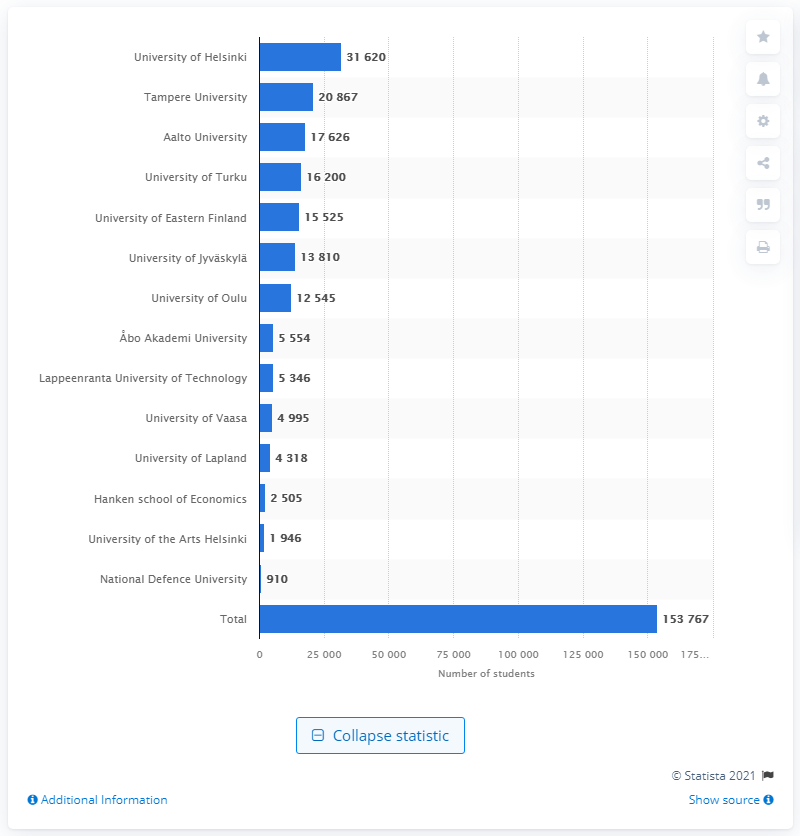Point out several critical features in this image. Tampere University is the second largest university in Finland. 